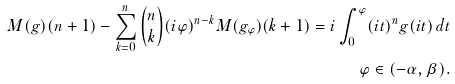Convert formula to latex. <formula><loc_0><loc_0><loc_500><loc_500>M ( g ) ( n + 1 ) - \sum _ { k = 0 } ^ { n } \binom { n } { k } ( i \varphi ) ^ { n - k } M ( g _ { \varphi } ) ( k + 1 ) = i \int _ { 0 } ^ { \varphi } ( i t ) ^ { n } g ( i t ) \, d t \\ \varphi \in ( - \alpha , \beta ) .</formula> 